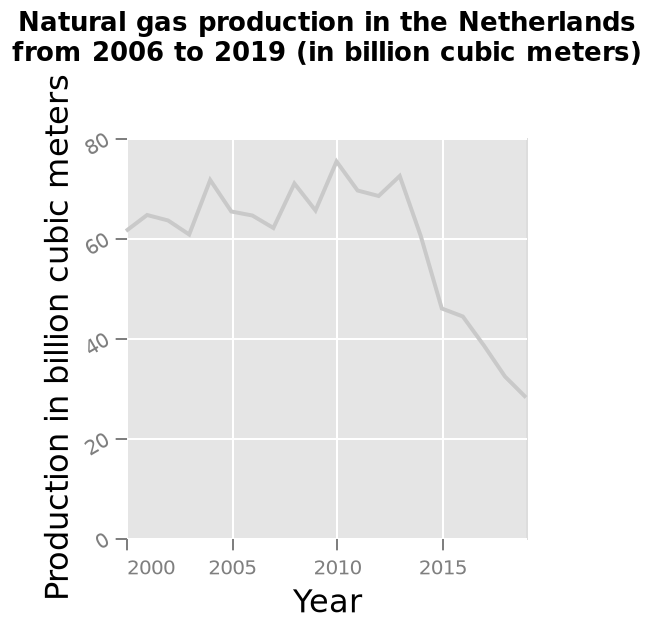<image>
Has there been any change in natural gas production since 2013? Yes, there has been a decline in natural gas production since 2013. Offer a thorough analysis of the image. The natural gas production declined from roughly 2013 onwards. Did natural gas production increase or decrease after 2013? Natural gas production decreased after 2013. When did the decline in natural gas production start? The decline in natural gas production started around 2013. 